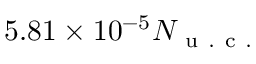Convert formula to latex. <formula><loc_0><loc_0><loc_500><loc_500>5 . 8 1 \times 1 0 ^ { - 5 } N _ { u . c . }</formula> 